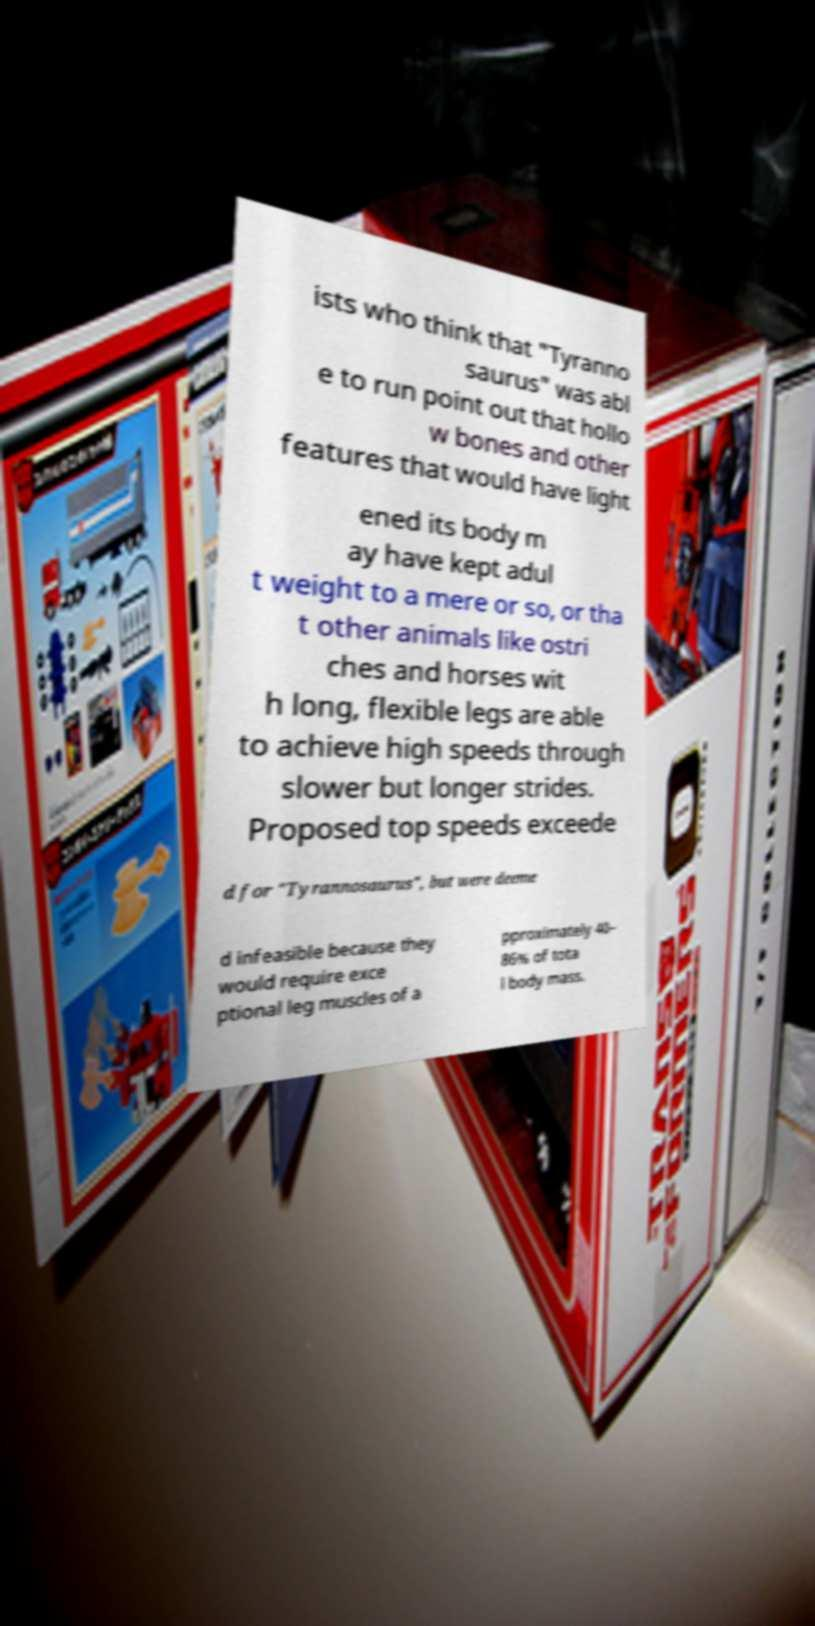Could you assist in decoding the text presented in this image and type it out clearly? ists who think that "Tyranno saurus" was abl e to run point out that hollo w bones and other features that would have light ened its body m ay have kept adul t weight to a mere or so, or tha t other animals like ostri ches and horses wit h long, flexible legs are able to achieve high speeds through slower but longer strides. Proposed top speeds exceede d for "Tyrannosaurus", but were deeme d infeasible because they would require exce ptional leg muscles of a pproximately 40– 86% of tota l body mass. 